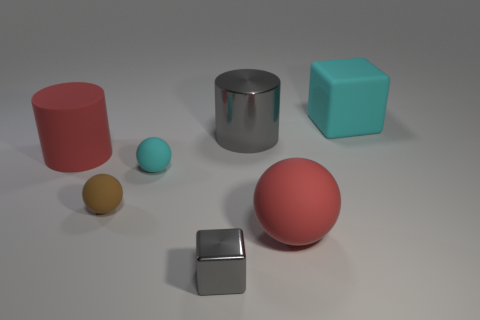Add 1 tiny metallic cubes. How many objects exist? 8 Subtract all balls. How many objects are left? 4 Subtract 1 red spheres. How many objects are left? 6 Subtract all tiny purple metallic balls. Subtract all cyan cubes. How many objects are left? 6 Add 3 small cyan spheres. How many small cyan spheres are left? 4 Add 5 large shiny objects. How many large shiny objects exist? 6 